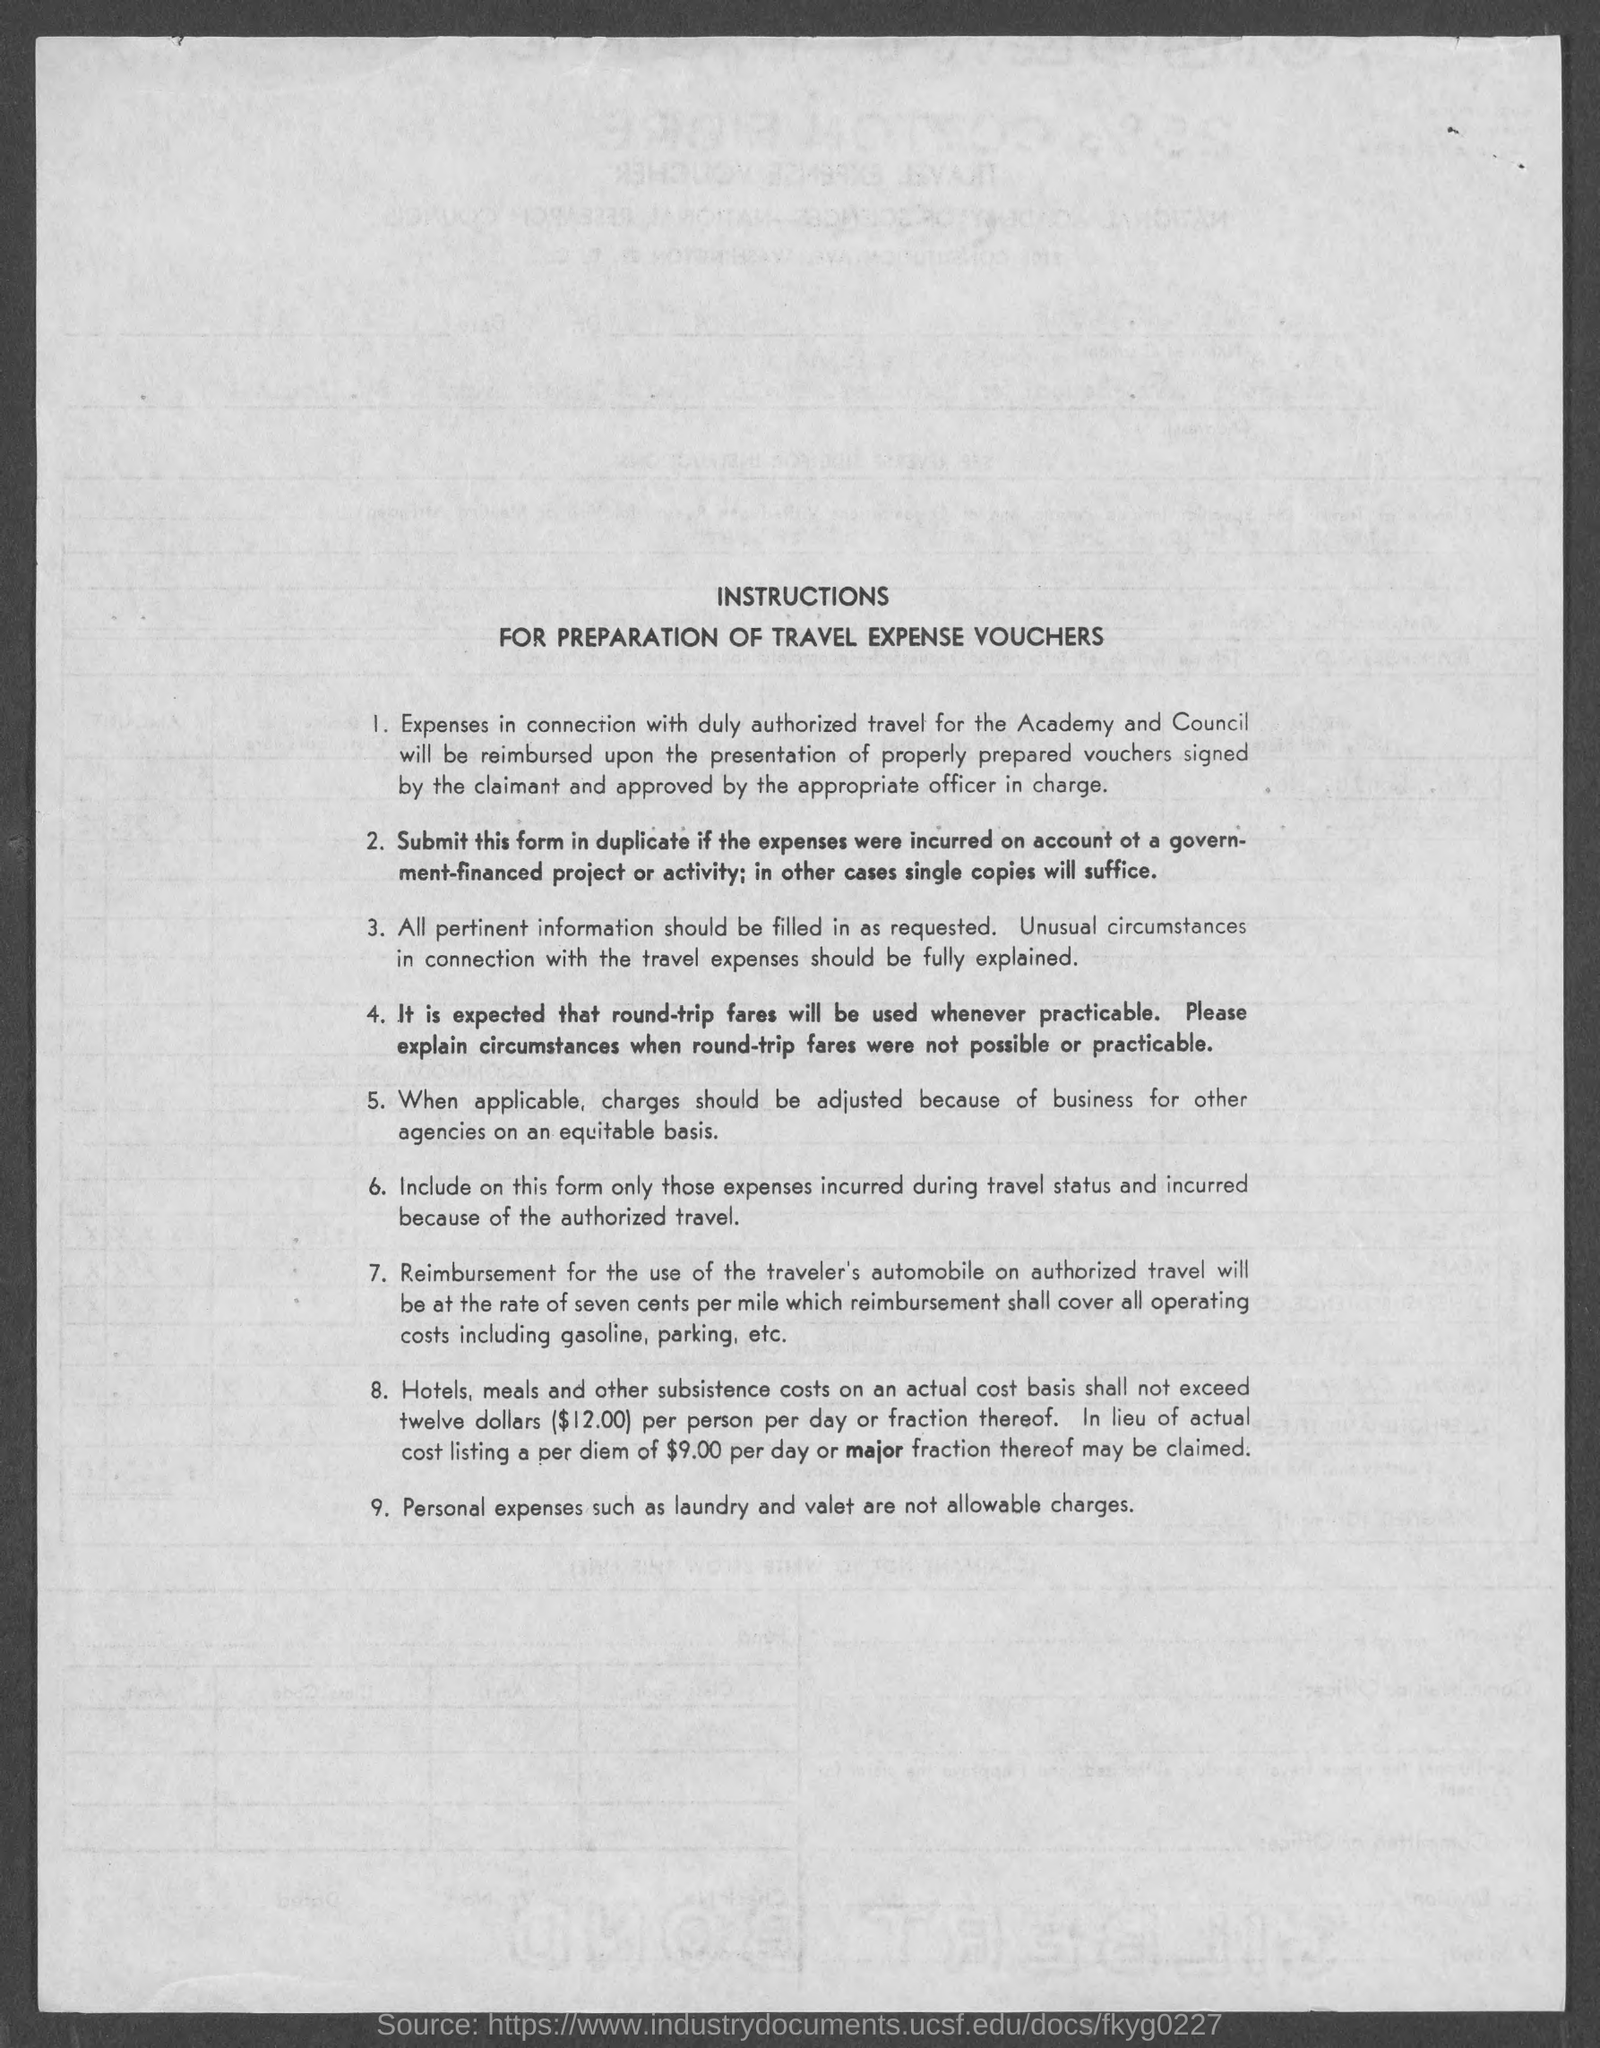Identify some key points in this picture. The title of the document is "Instructions for Preparation of Travel Expense Vouchers. 